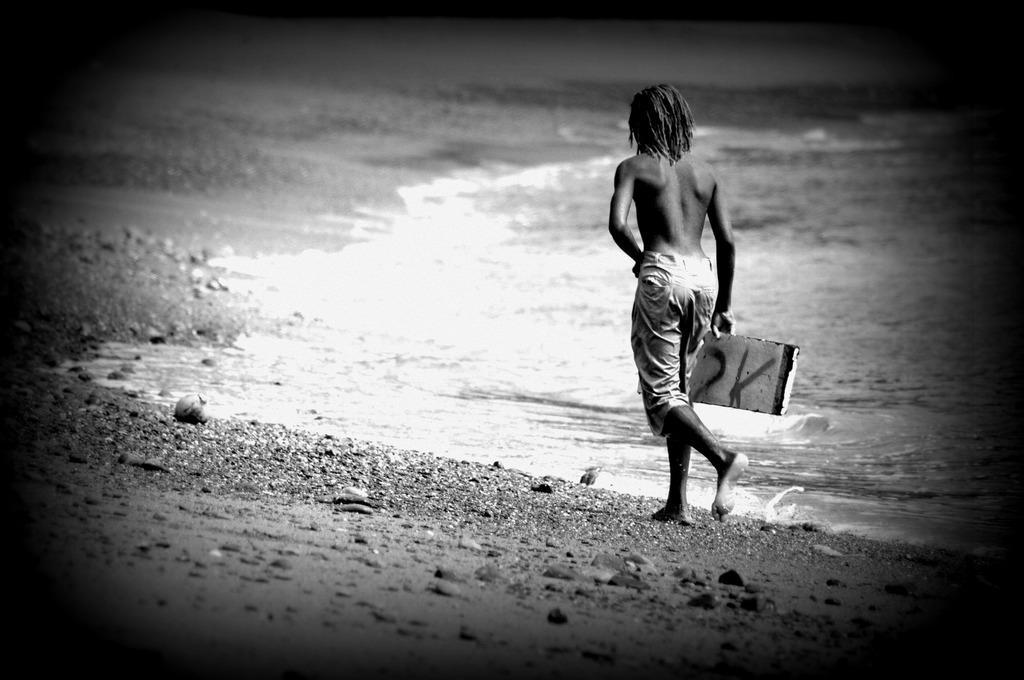Could you give a brief overview of what you see in this image? This is the black and white picture of a person walking on the side of beach without shirt. 